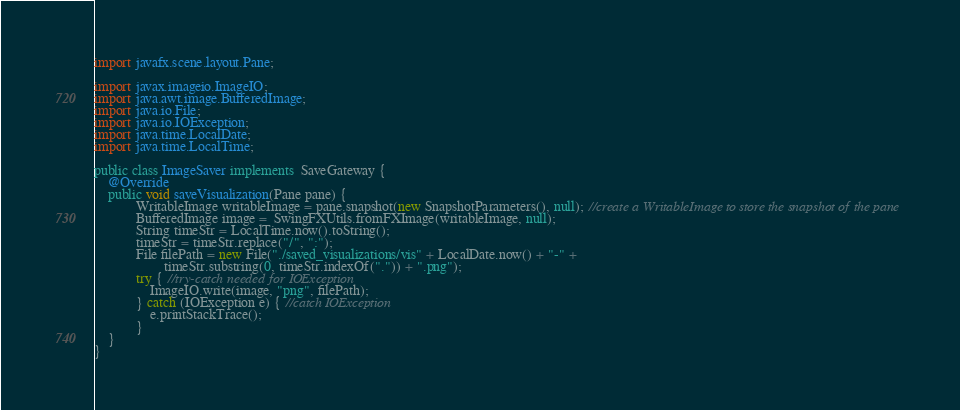<code> <loc_0><loc_0><loc_500><loc_500><_Java_>import javafx.scene.layout.Pane;

import javax.imageio.ImageIO;
import java.awt.image.BufferedImage;
import java.io.File;
import java.io.IOException;
import java.time.LocalDate;
import java.time.LocalTime;

public class ImageSaver implements  SaveGateway {
    @Override
    public void saveVisualization(Pane pane) {
            WritableImage writableImage = pane.snapshot(new SnapshotParameters(), null); //create a WritableImage to store the snapshot of the pane
            BufferedImage image =  SwingFXUtils.fromFXImage(writableImage, null);
            String timeStr = LocalTime.now().toString();
            timeStr = timeStr.replace("/", ":");
            File filePath = new File("./saved_visualizations/vis" + LocalDate.now() + "-" +
                    timeStr.substring(0, timeStr.indexOf(".")) + ".png");
            try { //try-catch needed for IOException
                ImageIO.write(image, "png", filePath);
            } catch (IOException e) { //catch IOException
                e.printStackTrace();
            }
    }
}
</code> 